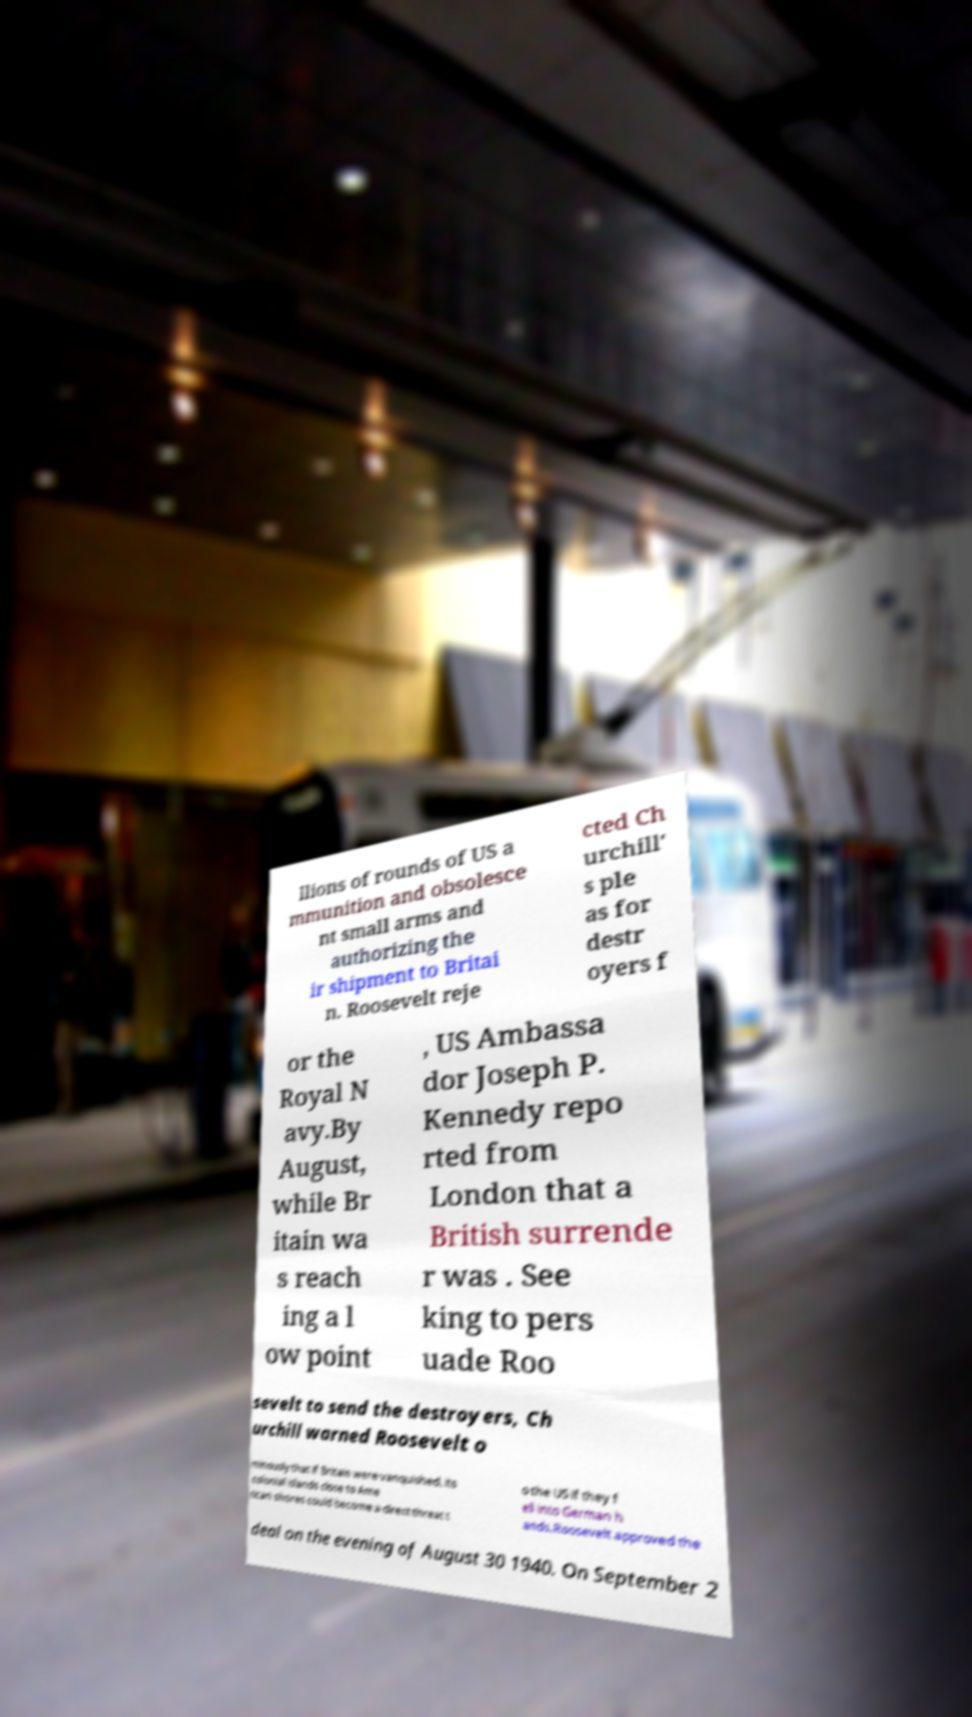Can you read and provide the text displayed in the image?This photo seems to have some interesting text. Can you extract and type it out for me? llions of rounds of US a mmunition and obsolesce nt small arms and authorizing the ir shipment to Britai n. Roosevelt reje cted Ch urchill' s ple as for destr oyers f or the Royal N avy.By August, while Br itain wa s reach ing a l ow point , US Ambassa dor Joseph P. Kennedy repo rted from London that a British surrende r was . See king to pers uade Roo sevelt to send the destroyers, Ch urchill warned Roosevelt o minously that if Britain were vanquished, its colonial islands close to Ame rican shores could become a direct threat t o the US if they f ell into German h ands.Roosevelt approved the deal on the evening of August 30 1940. On September 2 